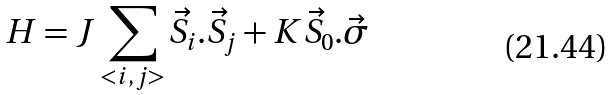<formula> <loc_0><loc_0><loc_500><loc_500>H = J \sum _ { < i , j > } \vec { S } _ { i } . \vec { S } _ { j } + K \vec { S } _ { 0 } . \vec { \sigma }</formula> 